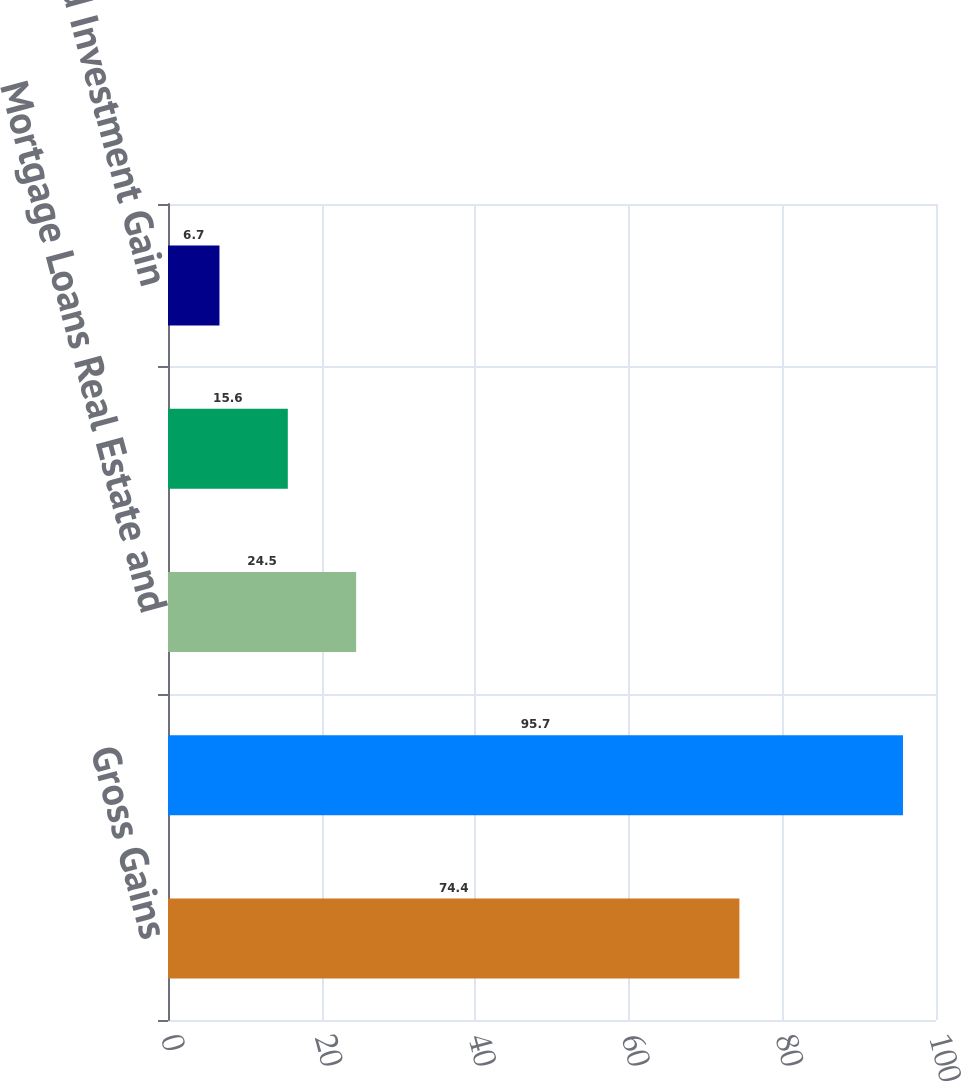<chart> <loc_0><loc_0><loc_500><loc_500><bar_chart><fcel>Gross Gains<fcel>Gross Losses<fcel>Mortgage Loans Real Estate and<fcel>Change in Fair Value of DIG<fcel>Realized Investment Gain<nl><fcel>74.4<fcel>95.7<fcel>24.5<fcel>15.6<fcel>6.7<nl></chart> 